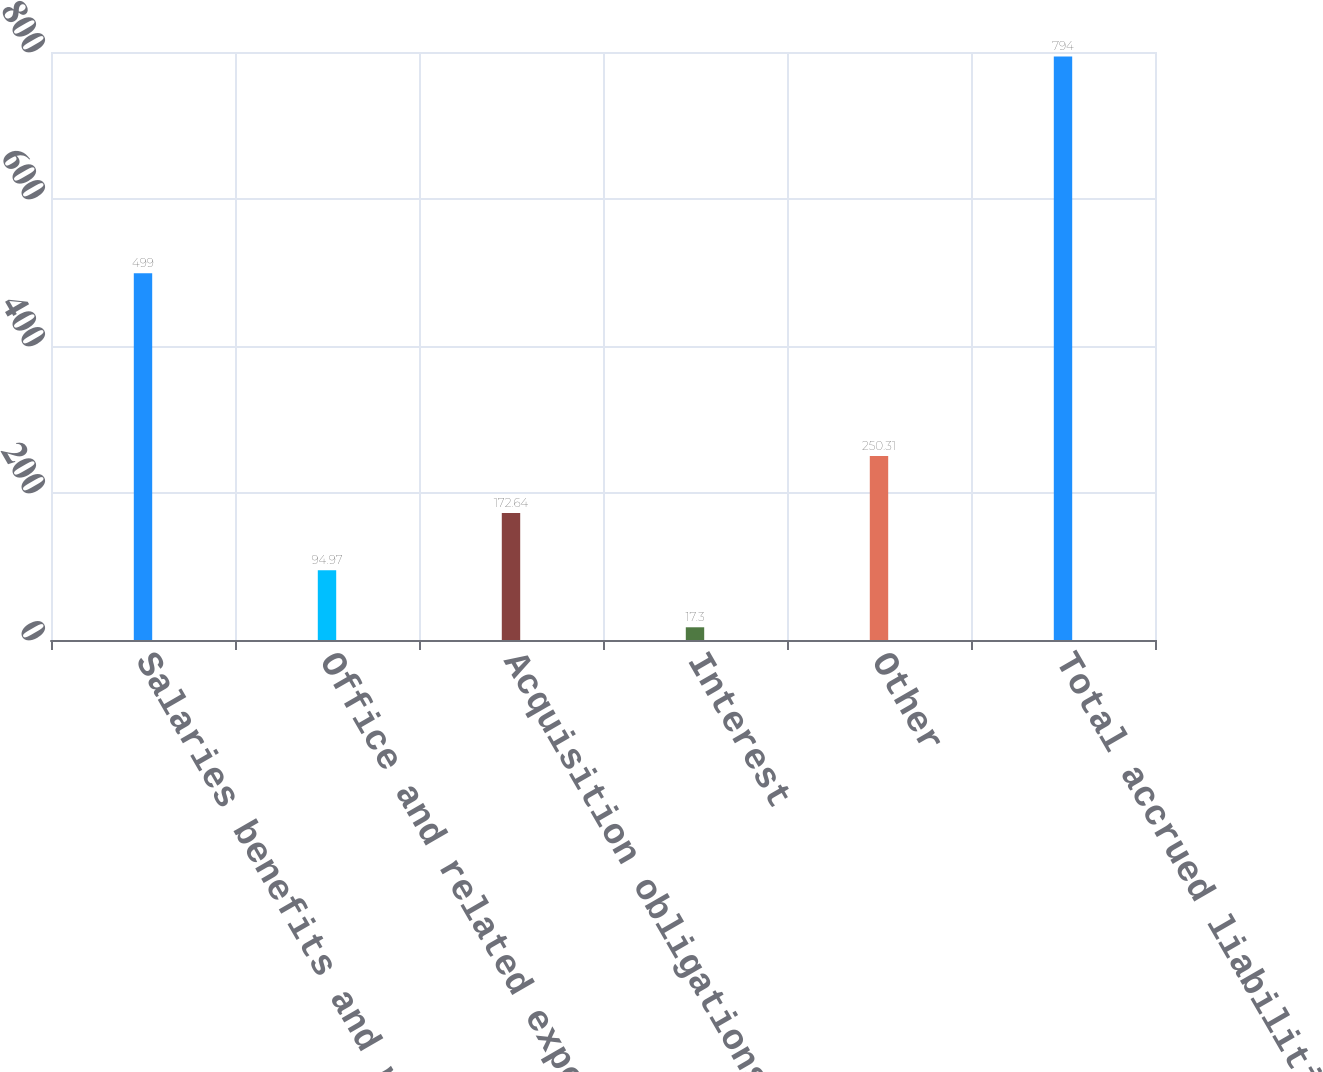<chart> <loc_0><loc_0><loc_500><loc_500><bar_chart><fcel>Salaries benefits and related<fcel>Office and related expenses<fcel>Acquisition obligations<fcel>Interest<fcel>Other<fcel>Total accrued liabilities<nl><fcel>499<fcel>94.97<fcel>172.64<fcel>17.3<fcel>250.31<fcel>794<nl></chart> 